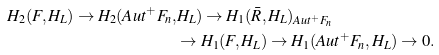Convert formula to latex. <formula><loc_0><loc_0><loc_500><loc_500>H _ { 2 } ( F , H _ { L } ) \rightarrow H _ { 2 } ( A u t ^ { + } F _ { n } , & H _ { L } ) \rightarrow H _ { 1 } ( \bar { R } , H _ { L } ) _ { A u t ^ { + } F _ { n } } \\ & \rightarrow H _ { 1 } ( F , H _ { L } ) \rightarrow H _ { 1 } ( A u t ^ { + } F _ { n } , H _ { L } ) \rightarrow 0 .</formula> 